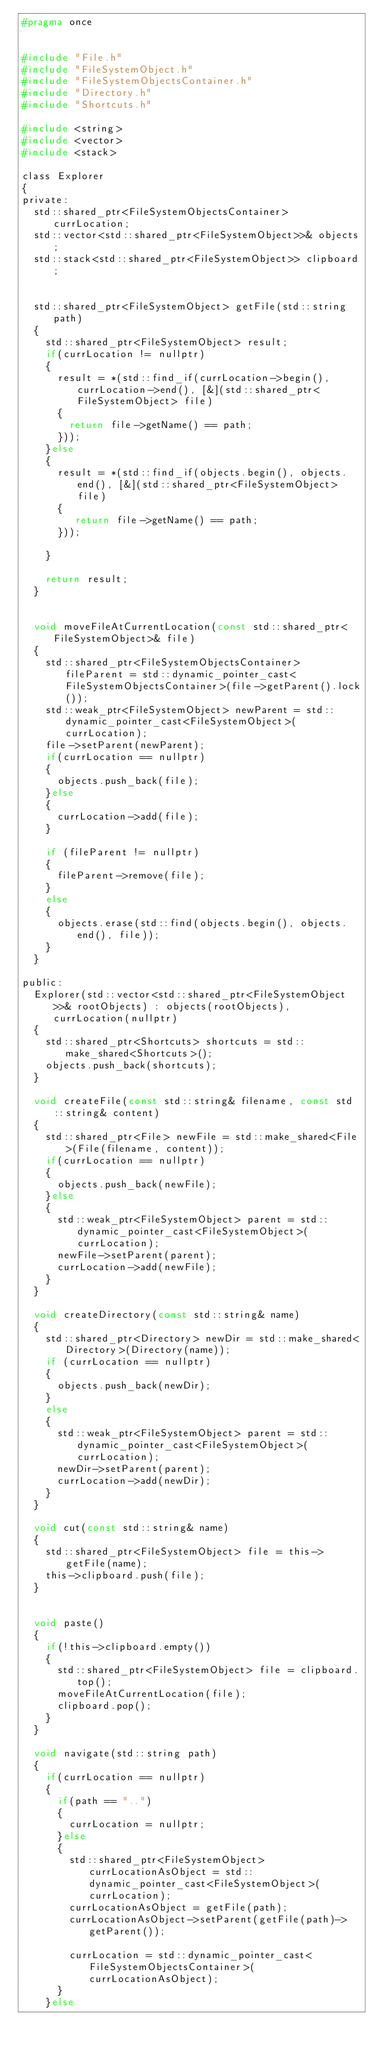<code> <loc_0><loc_0><loc_500><loc_500><_C_>#pragma once


#include "File.h"
#include "FileSystemObject.h"
#include "FileSystemObjectsContainer.h"
#include "Directory.h"
#include "Shortcuts.h"

#include <string>
#include <vector>
#include <stack>

class Explorer
{
private:
	std::shared_ptr<FileSystemObjectsContainer> currLocation;
	std::vector<std::shared_ptr<FileSystemObject>>& objects;
	std::stack<std::shared_ptr<FileSystemObject>> clipboard;


	std::shared_ptr<FileSystemObject> getFile(std::string path)
	{
		std::shared_ptr<FileSystemObject> result;
		if(currLocation != nullptr)
		{
			result = *(std::find_if(currLocation->begin(), currLocation->end(), [&](std::shared_ptr<FileSystemObject> file)
			{
				return file->getName() == path;
			}));
		}else
		{
			result = *(std::find_if(objects.begin(), objects.end(), [&](std::shared_ptr<FileSystemObject> file)
			{
				 return file->getName() == path;
			}));
			
		}

		return result;
	}


	void moveFileAtCurrentLocation(const std::shared_ptr<FileSystemObject>& file)
	{
		std::shared_ptr<FileSystemObjectsContainer> fileParent = std::dynamic_pointer_cast<FileSystemObjectsContainer>(file->getParent().lock());
		std::weak_ptr<FileSystemObject> newParent = std::dynamic_pointer_cast<FileSystemObject>(currLocation);
		file->setParent(newParent);
		if(currLocation == nullptr)
		{
			objects.push_back(file);
		}else
		{
			currLocation->add(file);
		}

		if (fileParent != nullptr)
		{
			fileParent->remove(file);
		}
		else
		{
			objects.erase(std::find(objects.begin(), objects.end(), file));
		}
	}

public:
	Explorer(std::vector<std::shared_ptr<FileSystemObject>>& rootObjects) : objects(rootObjects), currLocation(nullptr)
	{
		std::shared_ptr<Shortcuts> shortcuts = std::make_shared<Shortcuts>();
		objects.push_back(shortcuts);
	}

	void createFile(const std::string& filename, const std::string& content)
	{
		std::shared_ptr<File> newFile = std::make_shared<File>(File(filename, content));
		if(currLocation == nullptr)
		{
			objects.push_back(newFile);
		}else
		{
			std::weak_ptr<FileSystemObject> parent = std::dynamic_pointer_cast<FileSystemObject>(currLocation);
			newFile->setParent(parent);
			currLocation->add(newFile);
		}
	}

	void createDirectory(const std::string& name)
	{
		std::shared_ptr<Directory> newDir = std::make_shared<Directory>(Directory(name));
		if (currLocation == nullptr)
		{
			objects.push_back(newDir);
		}
		else
		{
			std::weak_ptr<FileSystemObject> parent = std::dynamic_pointer_cast<FileSystemObject>(currLocation);
			newDir->setParent(parent);
			currLocation->add(newDir);
		}
	}

	void cut(const std::string& name)
	{
		std::shared_ptr<FileSystemObject> file = this->getFile(name);
		this->clipboard.push(file);
	}


	void paste()
	{
		if(!this->clipboard.empty())
		{
			std::shared_ptr<FileSystemObject> file = clipboard.top();
			moveFileAtCurrentLocation(file);
			clipboard.pop();
		}
	}

	void navigate(std::string path)
	{
		if(currLocation == nullptr)
		{
			if(path == "..")
			{
				currLocation = nullptr;
			}else
			{
				std::shared_ptr<FileSystemObject> currLocationAsObject = std::dynamic_pointer_cast<FileSystemObject>(currLocation);
				currLocationAsObject = getFile(path);
				currLocationAsObject->setParent(getFile(path)->getParent());

				currLocation = std::dynamic_pointer_cast<FileSystemObjectsContainer>(currLocationAsObject);
			}
		}else</code> 